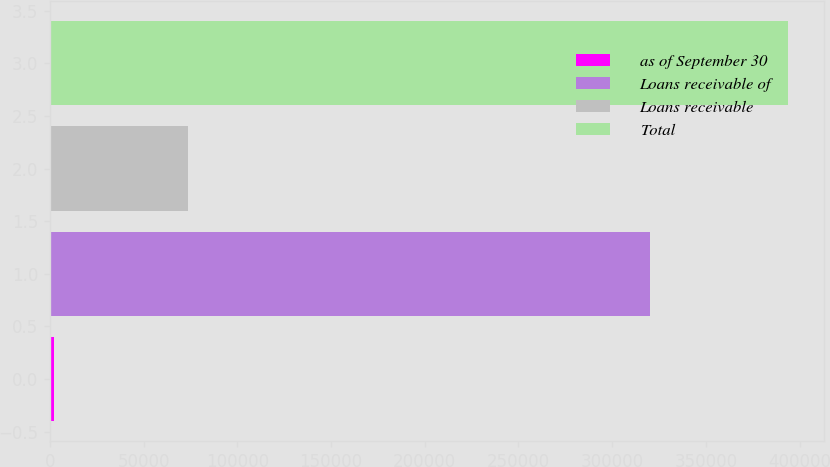Convert chart. <chart><loc_0><loc_0><loc_500><loc_500><bar_chart><fcel>as of September 30<fcel>Loans receivable of<fcel>Loans receivable<fcel>Total<nl><fcel>2010<fcel>319976<fcel>73602<fcel>393578<nl></chart> 